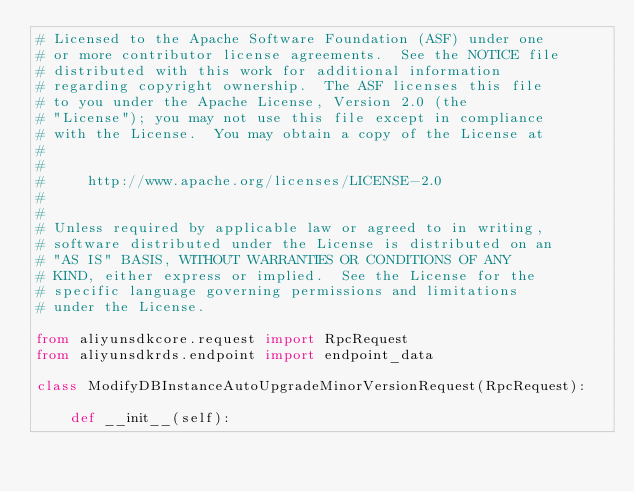Convert code to text. <code><loc_0><loc_0><loc_500><loc_500><_Python_># Licensed to the Apache Software Foundation (ASF) under one
# or more contributor license agreements.  See the NOTICE file
# distributed with this work for additional information
# regarding copyright ownership.  The ASF licenses this file
# to you under the Apache License, Version 2.0 (the
# "License"); you may not use this file except in compliance
# with the License.  You may obtain a copy of the License at
#
#
#     http://www.apache.org/licenses/LICENSE-2.0
#
#
# Unless required by applicable law or agreed to in writing,
# software distributed under the License is distributed on an
# "AS IS" BASIS, WITHOUT WARRANTIES OR CONDITIONS OF ANY
# KIND, either express or implied.  See the License for the
# specific language governing permissions and limitations
# under the License.

from aliyunsdkcore.request import RpcRequest
from aliyunsdkrds.endpoint import endpoint_data

class ModifyDBInstanceAutoUpgradeMinorVersionRequest(RpcRequest):

	def __init__(self):</code> 